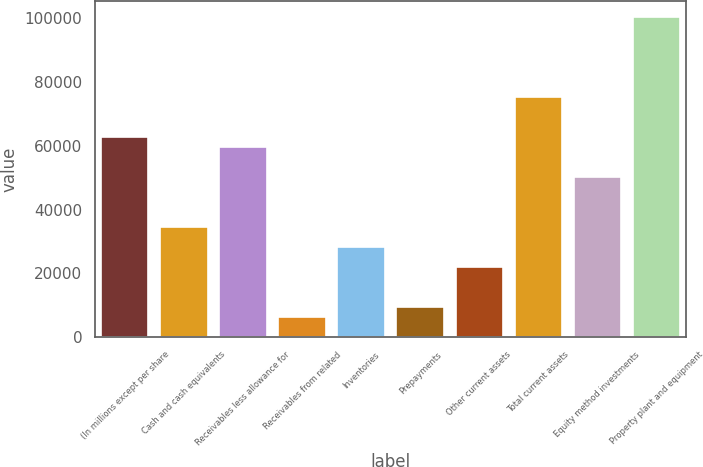Convert chart to OTSL. <chart><loc_0><loc_0><loc_500><loc_500><bar_chart><fcel>(In millions except per share<fcel>Cash and cash equivalents<fcel>Receivables less allowance for<fcel>Receivables from related<fcel>Inventories<fcel>Prepayments<fcel>Other current assets<fcel>Total current assets<fcel>Equity method investments<fcel>Property plant and equipment<nl><fcel>62737<fcel>34507.6<fcel>59600.4<fcel>6278.2<fcel>28234.4<fcel>9414.8<fcel>21961.2<fcel>75283.4<fcel>50190.6<fcel>100376<nl></chart> 